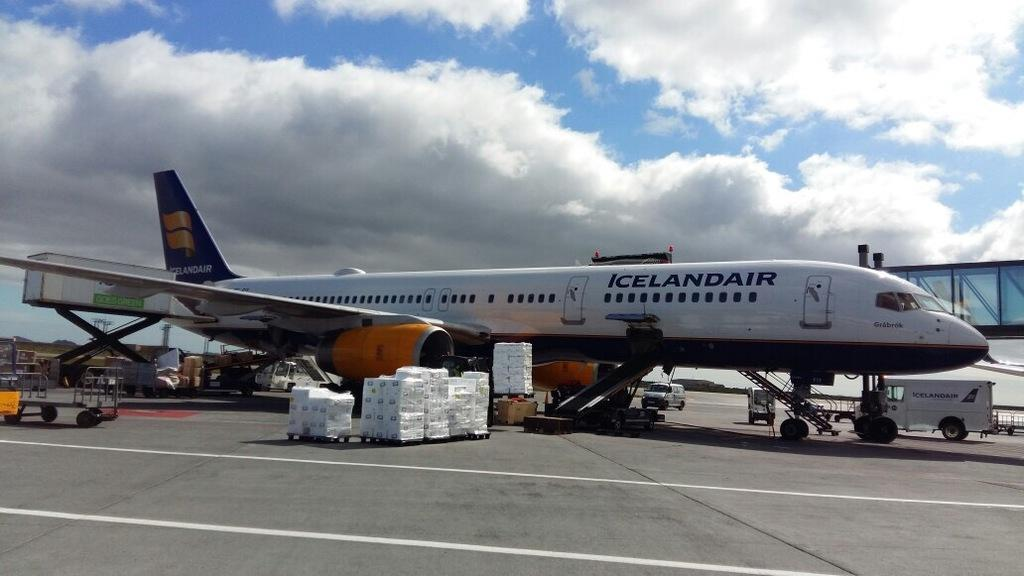<image>
Share a concise interpretation of the image provided. A white and blue airplane from the company Iceland Air 